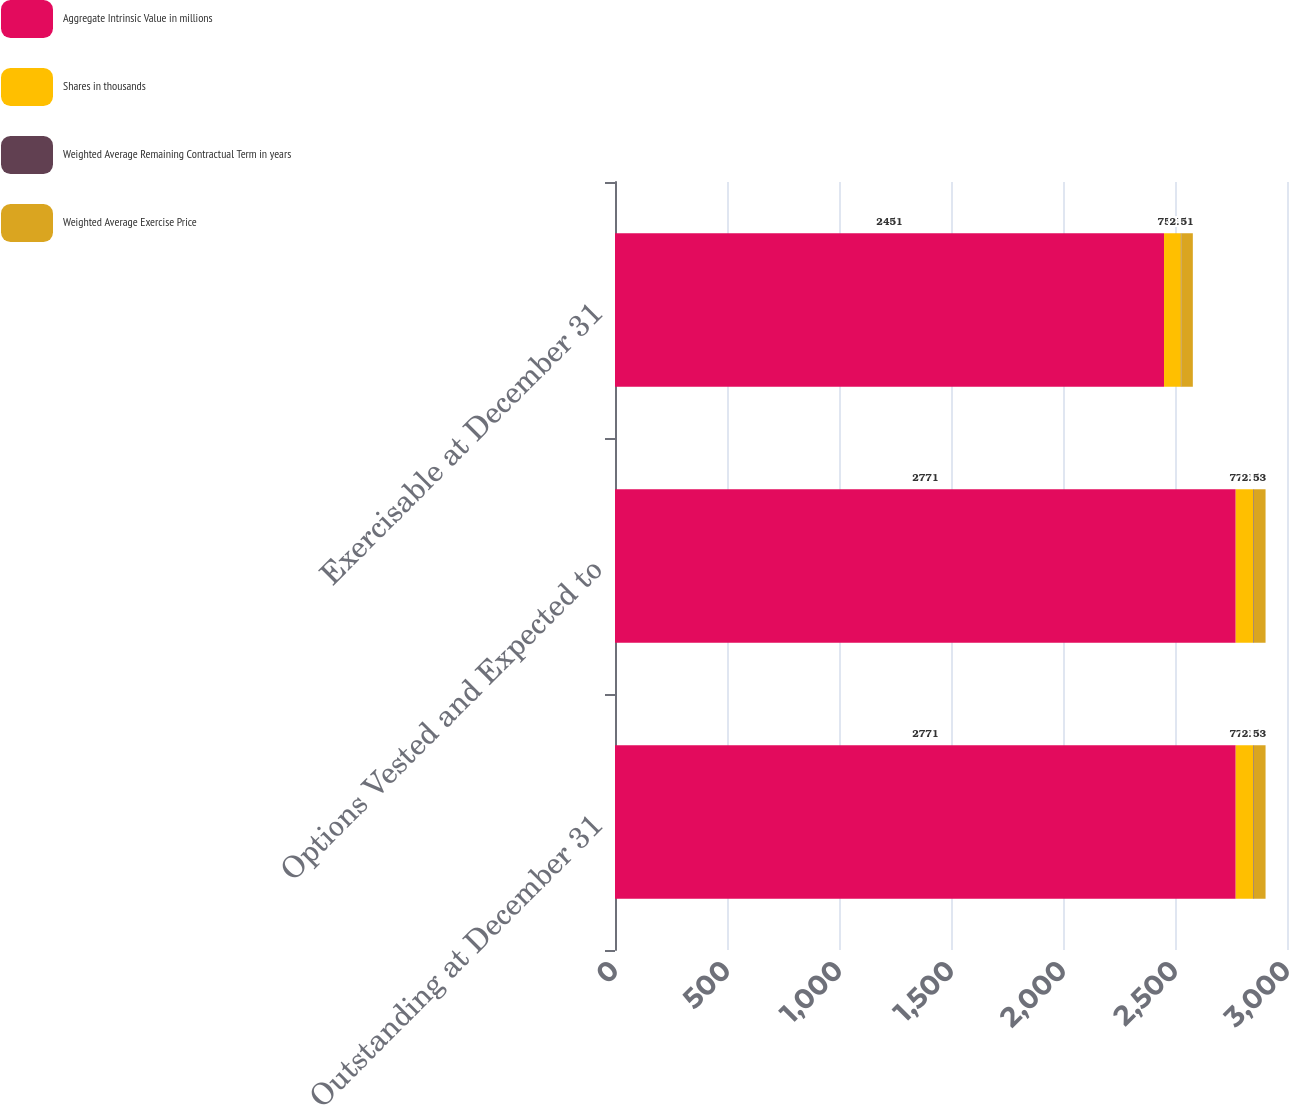<chart> <loc_0><loc_0><loc_500><loc_500><stacked_bar_chart><ecel><fcel>Outstanding at December 31<fcel>Options Vested and Expected to<fcel>Exercisable at December 31<nl><fcel>Aggregate Intrinsic Value in millions<fcel>2771<fcel>2771<fcel>2451<nl><fcel>Shares in thousands<fcel>77.33<fcel>77.33<fcel>75.31<nl><fcel>Weighted Average Remaining Contractual Term in years<fcel>2.94<fcel>2.94<fcel>2.27<nl><fcel>Weighted Average Exercise Price<fcel>53<fcel>53<fcel>51<nl></chart> 